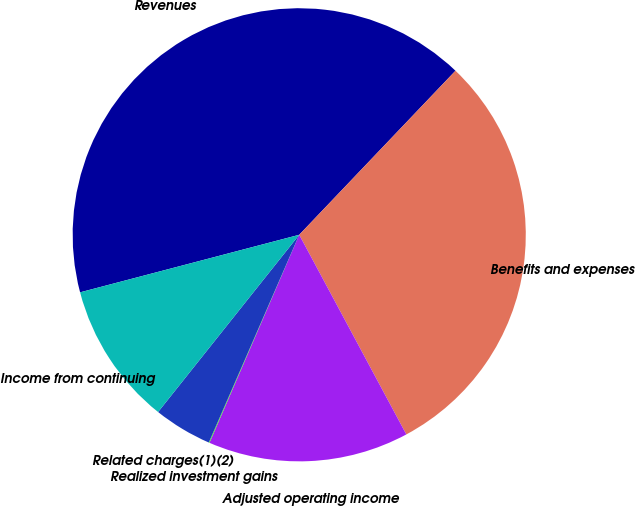Convert chart. <chart><loc_0><loc_0><loc_500><loc_500><pie_chart><fcel>Revenues<fcel>Benefits and expenses<fcel>Adjusted operating income<fcel>Realized investment gains<fcel>Related charges(1)(2)<fcel>Income from continuing<nl><fcel>41.2%<fcel>30.05%<fcel>14.32%<fcel>0.05%<fcel>4.17%<fcel>10.21%<nl></chart> 